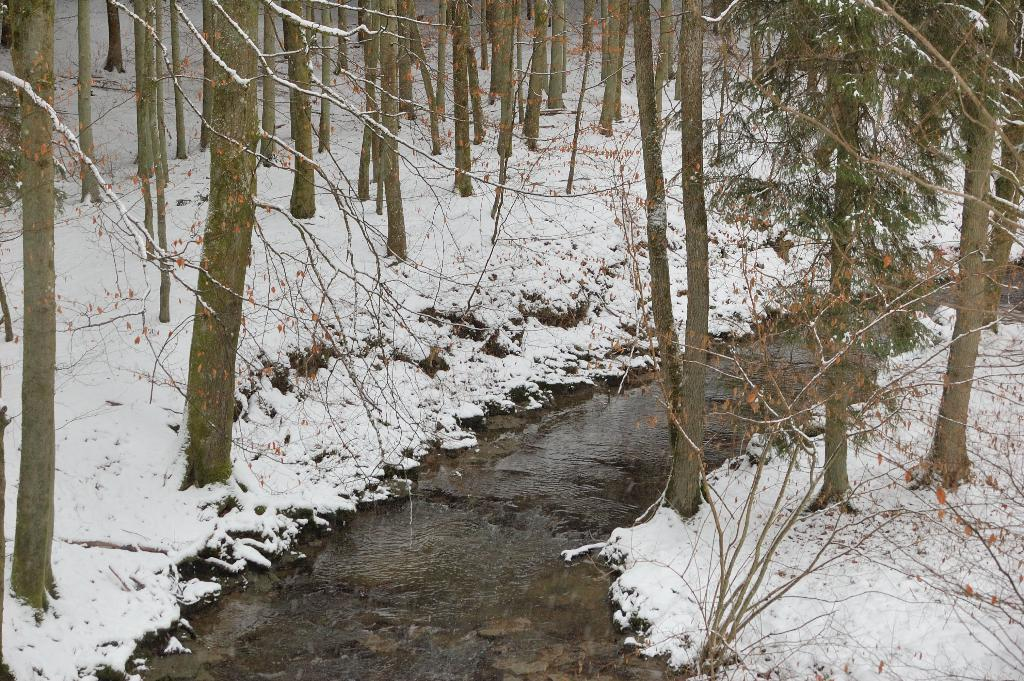What is one of the natural elements present in the image? There is water in the image. What is another natural element present in the image? There is snow in the image. What type of vegetation can be seen in the image? There are trees in the image. What type of lipstick is the tiger wearing in the image? There is no tiger or lipstick present in the image. What type of kettle can be seen boiling water in the image? There is no kettle present in the image. 